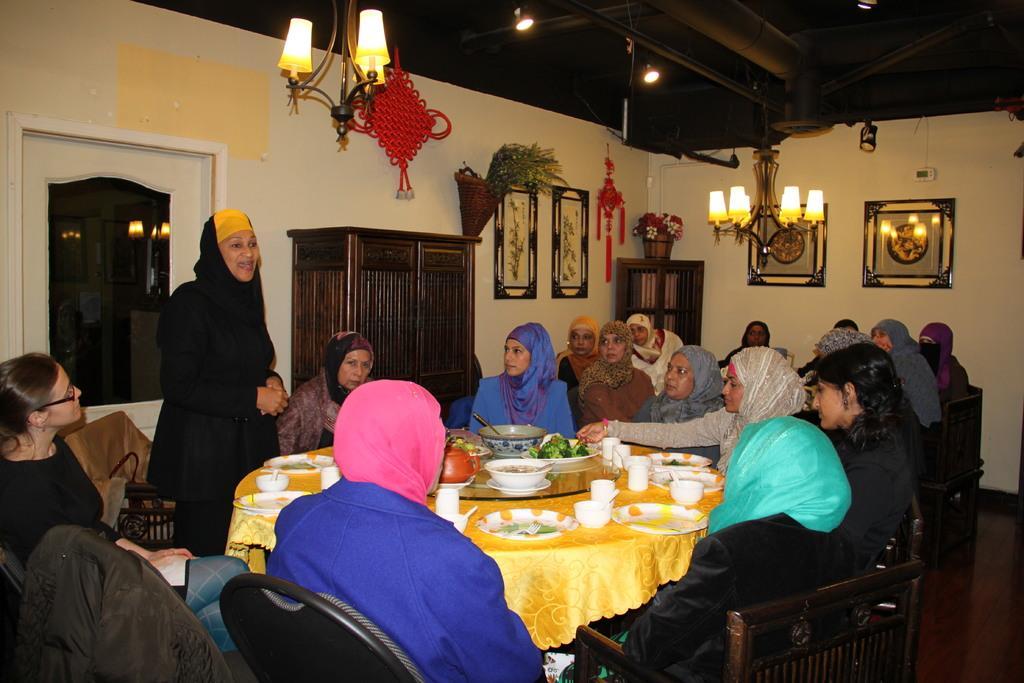Describe this image in one or two sentences. In this picture we can see some persons sitting on the chairs around the table. On the table there is a yellow colored cloth, plate, bowl, and cups. This is the floor. And here we can see a woman standing on the floor and talking to these people. And on the background there is a wall and these are the frames on to the wall. This is cupboard. And these are the lights. 